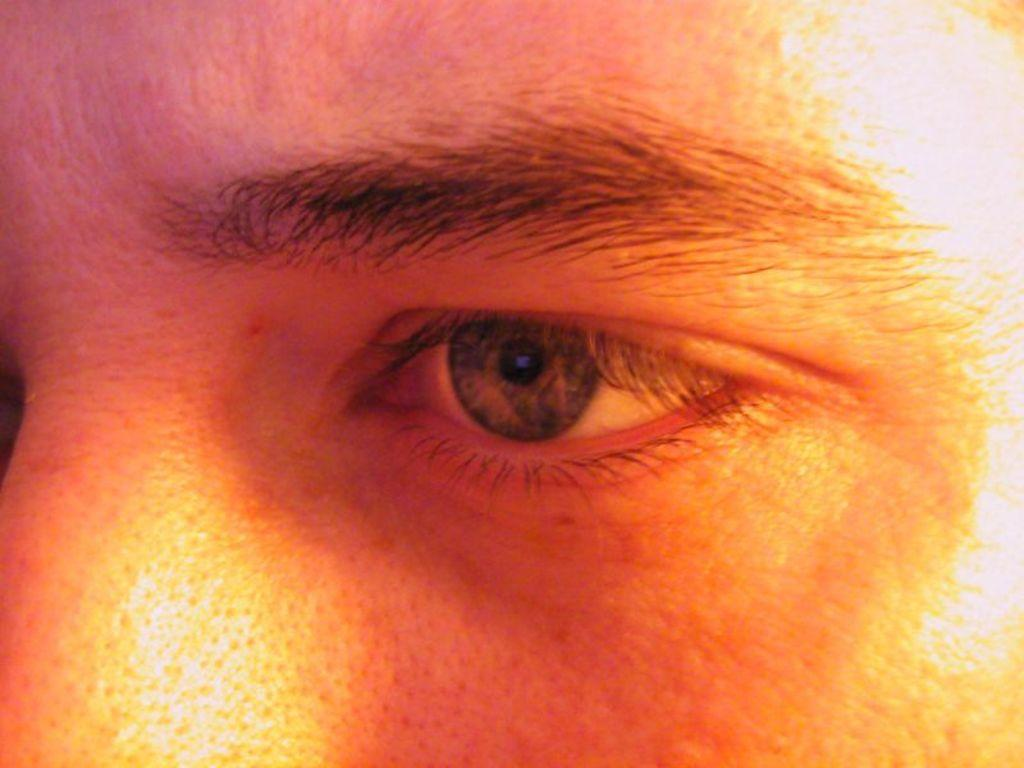What is the main subject of the image? There is a person in the image. Where is the playground located in the image? There is no playground present in the image; it only features a person. What is the person using to start the car in the image? There is no car or starting action depicted in the image; it only features a person. 